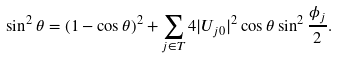<formula> <loc_0><loc_0><loc_500><loc_500>\sin ^ { 2 } \theta = ( 1 - \cos \theta ) ^ { 2 } + \sum _ { j \in T } 4 | U _ { j 0 } | ^ { 2 } \cos \theta \sin ^ { 2 } \frac { \phi _ { j } } { 2 } .</formula> 